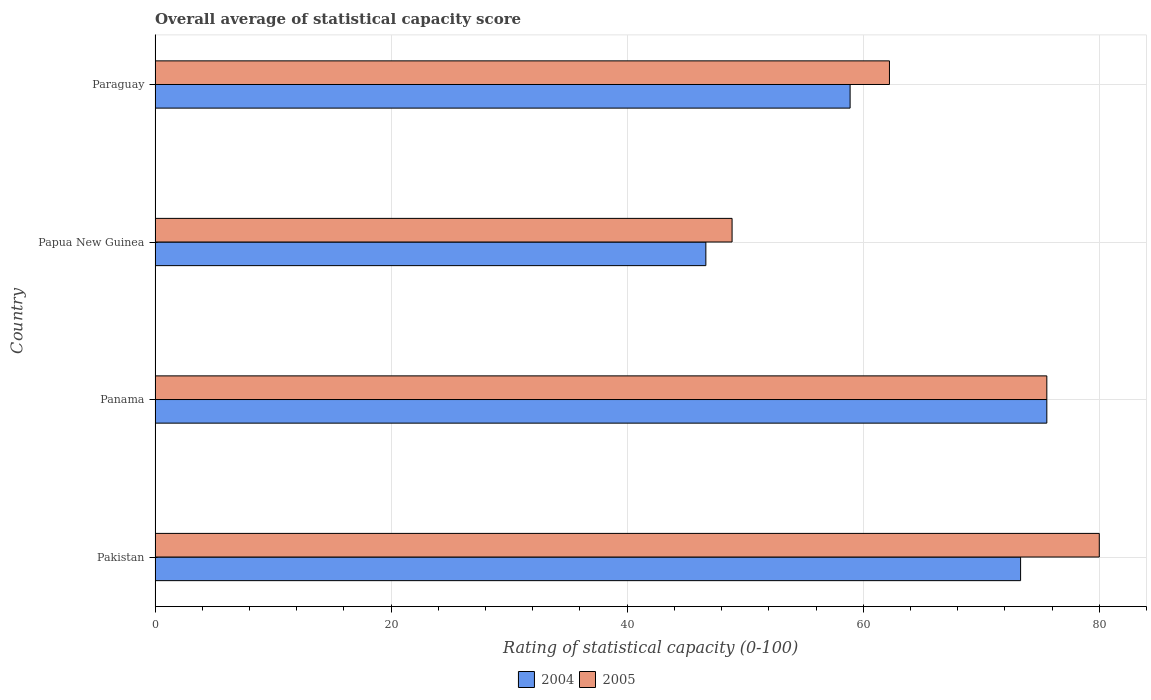What is the label of the 3rd group of bars from the top?
Your answer should be compact. Panama. In how many cases, is the number of bars for a given country not equal to the number of legend labels?
Give a very brief answer. 0. What is the rating of statistical capacity in 2004 in Papua New Guinea?
Provide a short and direct response. 46.67. Across all countries, what is the minimum rating of statistical capacity in 2004?
Your answer should be very brief. 46.67. In which country was the rating of statistical capacity in 2005 maximum?
Your answer should be compact. Pakistan. In which country was the rating of statistical capacity in 2004 minimum?
Your answer should be very brief. Papua New Guinea. What is the total rating of statistical capacity in 2004 in the graph?
Offer a very short reply. 254.44. What is the difference between the rating of statistical capacity in 2004 in Panama and that in Paraguay?
Provide a succinct answer. 16.67. What is the difference between the rating of statistical capacity in 2005 in Paraguay and the rating of statistical capacity in 2004 in Pakistan?
Offer a terse response. -11.11. What is the average rating of statistical capacity in 2004 per country?
Your answer should be very brief. 63.61. What is the difference between the rating of statistical capacity in 2004 and rating of statistical capacity in 2005 in Papua New Guinea?
Keep it short and to the point. -2.22. In how many countries, is the rating of statistical capacity in 2004 greater than 64 ?
Provide a short and direct response. 2. What is the ratio of the rating of statistical capacity in 2004 in Panama to that in Paraguay?
Make the answer very short. 1.28. Is the rating of statistical capacity in 2005 in Panama less than that in Paraguay?
Provide a succinct answer. No. Is the difference between the rating of statistical capacity in 2004 in Pakistan and Paraguay greater than the difference between the rating of statistical capacity in 2005 in Pakistan and Paraguay?
Your response must be concise. No. What is the difference between the highest and the second highest rating of statistical capacity in 2004?
Ensure brevity in your answer.  2.22. What is the difference between the highest and the lowest rating of statistical capacity in 2004?
Ensure brevity in your answer.  28.89. What does the 2nd bar from the top in Paraguay represents?
Your answer should be compact. 2004. What does the 2nd bar from the bottom in Pakistan represents?
Keep it short and to the point. 2005. How many countries are there in the graph?
Offer a terse response. 4. Does the graph contain any zero values?
Give a very brief answer. No. Does the graph contain grids?
Offer a very short reply. Yes. What is the title of the graph?
Your answer should be very brief. Overall average of statistical capacity score. Does "2010" appear as one of the legend labels in the graph?
Your answer should be compact. No. What is the label or title of the X-axis?
Keep it short and to the point. Rating of statistical capacity (0-100). What is the Rating of statistical capacity (0-100) of 2004 in Pakistan?
Your answer should be very brief. 73.33. What is the Rating of statistical capacity (0-100) in 2005 in Pakistan?
Provide a short and direct response. 80. What is the Rating of statistical capacity (0-100) of 2004 in Panama?
Make the answer very short. 75.56. What is the Rating of statistical capacity (0-100) of 2005 in Panama?
Provide a succinct answer. 75.56. What is the Rating of statistical capacity (0-100) in 2004 in Papua New Guinea?
Give a very brief answer. 46.67. What is the Rating of statistical capacity (0-100) of 2005 in Papua New Guinea?
Keep it short and to the point. 48.89. What is the Rating of statistical capacity (0-100) of 2004 in Paraguay?
Provide a short and direct response. 58.89. What is the Rating of statistical capacity (0-100) in 2005 in Paraguay?
Offer a very short reply. 62.22. Across all countries, what is the maximum Rating of statistical capacity (0-100) in 2004?
Your answer should be very brief. 75.56. Across all countries, what is the maximum Rating of statistical capacity (0-100) of 2005?
Your answer should be compact. 80. Across all countries, what is the minimum Rating of statistical capacity (0-100) of 2004?
Offer a terse response. 46.67. Across all countries, what is the minimum Rating of statistical capacity (0-100) in 2005?
Your response must be concise. 48.89. What is the total Rating of statistical capacity (0-100) in 2004 in the graph?
Make the answer very short. 254.44. What is the total Rating of statistical capacity (0-100) in 2005 in the graph?
Offer a terse response. 266.67. What is the difference between the Rating of statistical capacity (0-100) of 2004 in Pakistan and that in Panama?
Provide a short and direct response. -2.22. What is the difference between the Rating of statistical capacity (0-100) in 2005 in Pakistan and that in Panama?
Keep it short and to the point. 4.44. What is the difference between the Rating of statistical capacity (0-100) of 2004 in Pakistan and that in Papua New Guinea?
Ensure brevity in your answer.  26.67. What is the difference between the Rating of statistical capacity (0-100) of 2005 in Pakistan and that in Papua New Guinea?
Provide a short and direct response. 31.11. What is the difference between the Rating of statistical capacity (0-100) in 2004 in Pakistan and that in Paraguay?
Keep it short and to the point. 14.44. What is the difference between the Rating of statistical capacity (0-100) in 2005 in Pakistan and that in Paraguay?
Offer a very short reply. 17.78. What is the difference between the Rating of statistical capacity (0-100) of 2004 in Panama and that in Papua New Guinea?
Provide a succinct answer. 28.89. What is the difference between the Rating of statistical capacity (0-100) of 2005 in Panama and that in Papua New Guinea?
Give a very brief answer. 26.67. What is the difference between the Rating of statistical capacity (0-100) of 2004 in Panama and that in Paraguay?
Make the answer very short. 16.67. What is the difference between the Rating of statistical capacity (0-100) of 2005 in Panama and that in Paraguay?
Your answer should be compact. 13.33. What is the difference between the Rating of statistical capacity (0-100) in 2004 in Papua New Guinea and that in Paraguay?
Provide a short and direct response. -12.22. What is the difference between the Rating of statistical capacity (0-100) of 2005 in Papua New Guinea and that in Paraguay?
Your response must be concise. -13.33. What is the difference between the Rating of statistical capacity (0-100) in 2004 in Pakistan and the Rating of statistical capacity (0-100) in 2005 in Panama?
Provide a succinct answer. -2.22. What is the difference between the Rating of statistical capacity (0-100) in 2004 in Pakistan and the Rating of statistical capacity (0-100) in 2005 in Papua New Guinea?
Your answer should be compact. 24.44. What is the difference between the Rating of statistical capacity (0-100) in 2004 in Pakistan and the Rating of statistical capacity (0-100) in 2005 in Paraguay?
Give a very brief answer. 11.11. What is the difference between the Rating of statistical capacity (0-100) of 2004 in Panama and the Rating of statistical capacity (0-100) of 2005 in Papua New Guinea?
Give a very brief answer. 26.67. What is the difference between the Rating of statistical capacity (0-100) in 2004 in Panama and the Rating of statistical capacity (0-100) in 2005 in Paraguay?
Make the answer very short. 13.33. What is the difference between the Rating of statistical capacity (0-100) of 2004 in Papua New Guinea and the Rating of statistical capacity (0-100) of 2005 in Paraguay?
Provide a short and direct response. -15.56. What is the average Rating of statistical capacity (0-100) of 2004 per country?
Give a very brief answer. 63.61. What is the average Rating of statistical capacity (0-100) in 2005 per country?
Offer a very short reply. 66.67. What is the difference between the Rating of statistical capacity (0-100) in 2004 and Rating of statistical capacity (0-100) in 2005 in Pakistan?
Offer a very short reply. -6.67. What is the difference between the Rating of statistical capacity (0-100) of 2004 and Rating of statistical capacity (0-100) of 2005 in Papua New Guinea?
Provide a succinct answer. -2.22. What is the ratio of the Rating of statistical capacity (0-100) of 2004 in Pakistan to that in Panama?
Your answer should be compact. 0.97. What is the ratio of the Rating of statistical capacity (0-100) in 2005 in Pakistan to that in Panama?
Give a very brief answer. 1.06. What is the ratio of the Rating of statistical capacity (0-100) of 2004 in Pakistan to that in Papua New Guinea?
Make the answer very short. 1.57. What is the ratio of the Rating of statistical capacity (0-100) of 2005 in Pakistan to that in Papua New Guinea?
Ensure brevity in your answer.  1.64. What is the ratio of the Rating of statistical capacity (0-100) of 2004 in Pakistan to that in Paraguay?
Ensure brevity in your answer.  1.25. What is the ratio of the Rating of statistical capacity (0-100) of 2005 in Pakistan to that in Paraguay?
Make the answer very short. 1.29. What is the ratio of the Rating of statistical capacity (0-100) in 2004 in Panama to that in Papua New Guinea?
Offer a terse response. 1.62. What is the ratio of the Rating of statistical capacity (0-100) of 2005 in Panama to that in Papua New Guinea?
Provide a succinct answer. 1.55. What is the ratio of the Rating of statistical capacity (0-100) of 2004 in Panama to that in Paraguay?
Your response must be concise. 1.28. What is the ratio of the Rating of statistical capacity (0-100) of 2005 in Panama to that in Paraguay?
Your answer should be compact. 1.21. What is the ratio of the Rating of statistical capacity (0-100) in 2004 in Papua New Guinea to that in Paraguay?
Offer a very short reply. 0.79. What is the ratio of the Rating of statistical capacity (0-100) in 2005 in Papua New Guinea to that in Paraguay?
Ensure brevity in your answer.  0.79. What is the difference between the highest and the second highest Rating of statistical capacity (0-100) in 2004?
Offer a very short reply. 2.22. What is the difference between the highest and the second highest Rating of statistical capacity (0-100) in 2005?
Your answer should be very brief. 4.44. What is the difference between the highest and the lowest Rating of statistical capacity (0-100) of 2004?
Offer a very short reply. 28.89. What is the difference between the highest and the lowest Rating of statistical capacity (0-100) in 2005?
Give a very brief answer. 31.11. 